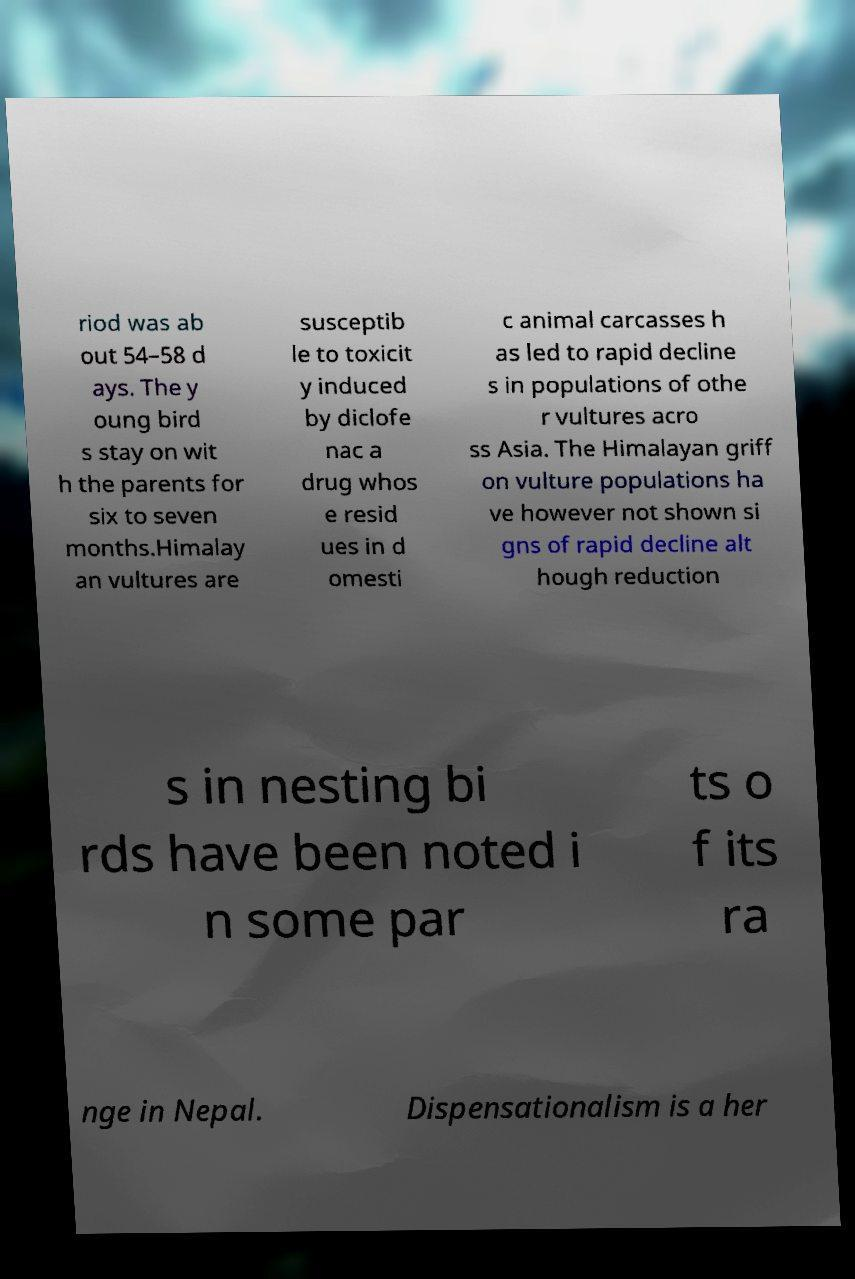Please identify and transcribe the text found in this image. riod was ab out 54–58 d ays. The y oung bird s stay on wit h the parents for six to seven months.Himalay an vultures are susceptib le to toxicit y induced by diclofe nac a drug whos e resid ues in d omesti c animal carcasses h as led to rapid decline s in populations of othe r vultures acro ss Asia. The Himalayan griff on vulture populations ha ve however not shown si gns of rapid decline alt hough reduction s in nesting bi rds have been noted i n some par ts o f its ra nge in Nepal. Dispensationalism is a her 